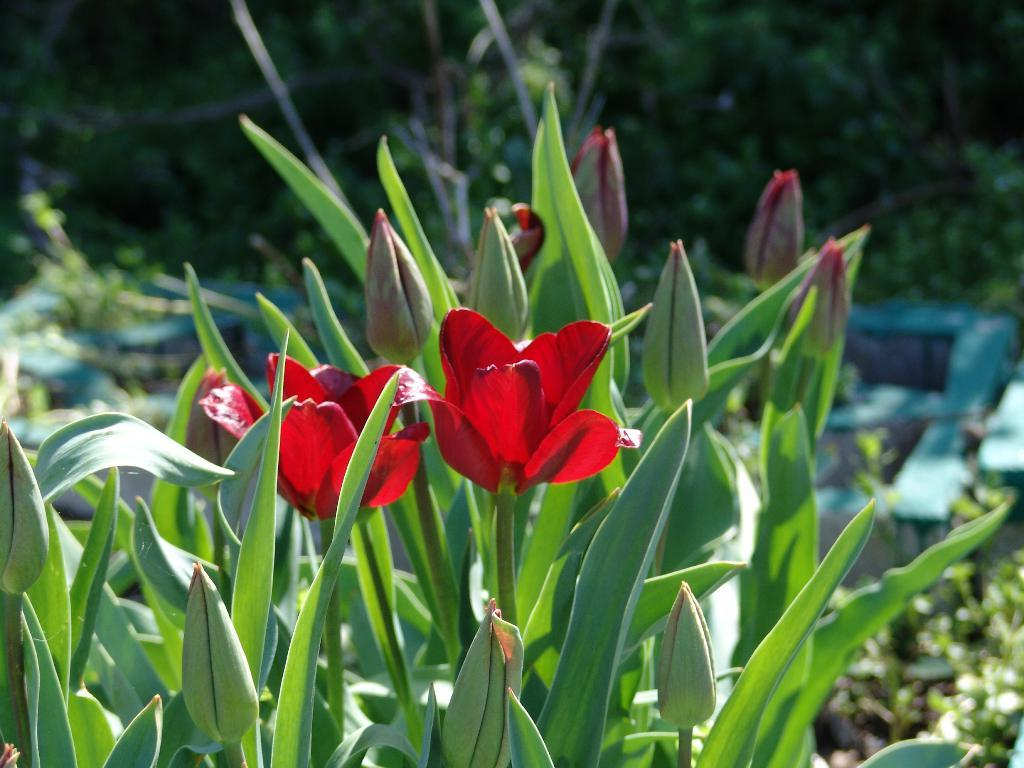What type of plants are in the image? There are red flower plants in the image. What color are the leaves of the red flower plants? The red flower plants have green leaves. Can you describe the background of the image? The background of the image is blurred. What type of pot is holding the red flower plants in the image? There is no pot visible in the image; the red flower plants are not shown in a pot. Whose hands can be seen holding the red flower plants in the image? There are no hands visible in the image; the red flower plants are not being held by anyone. 